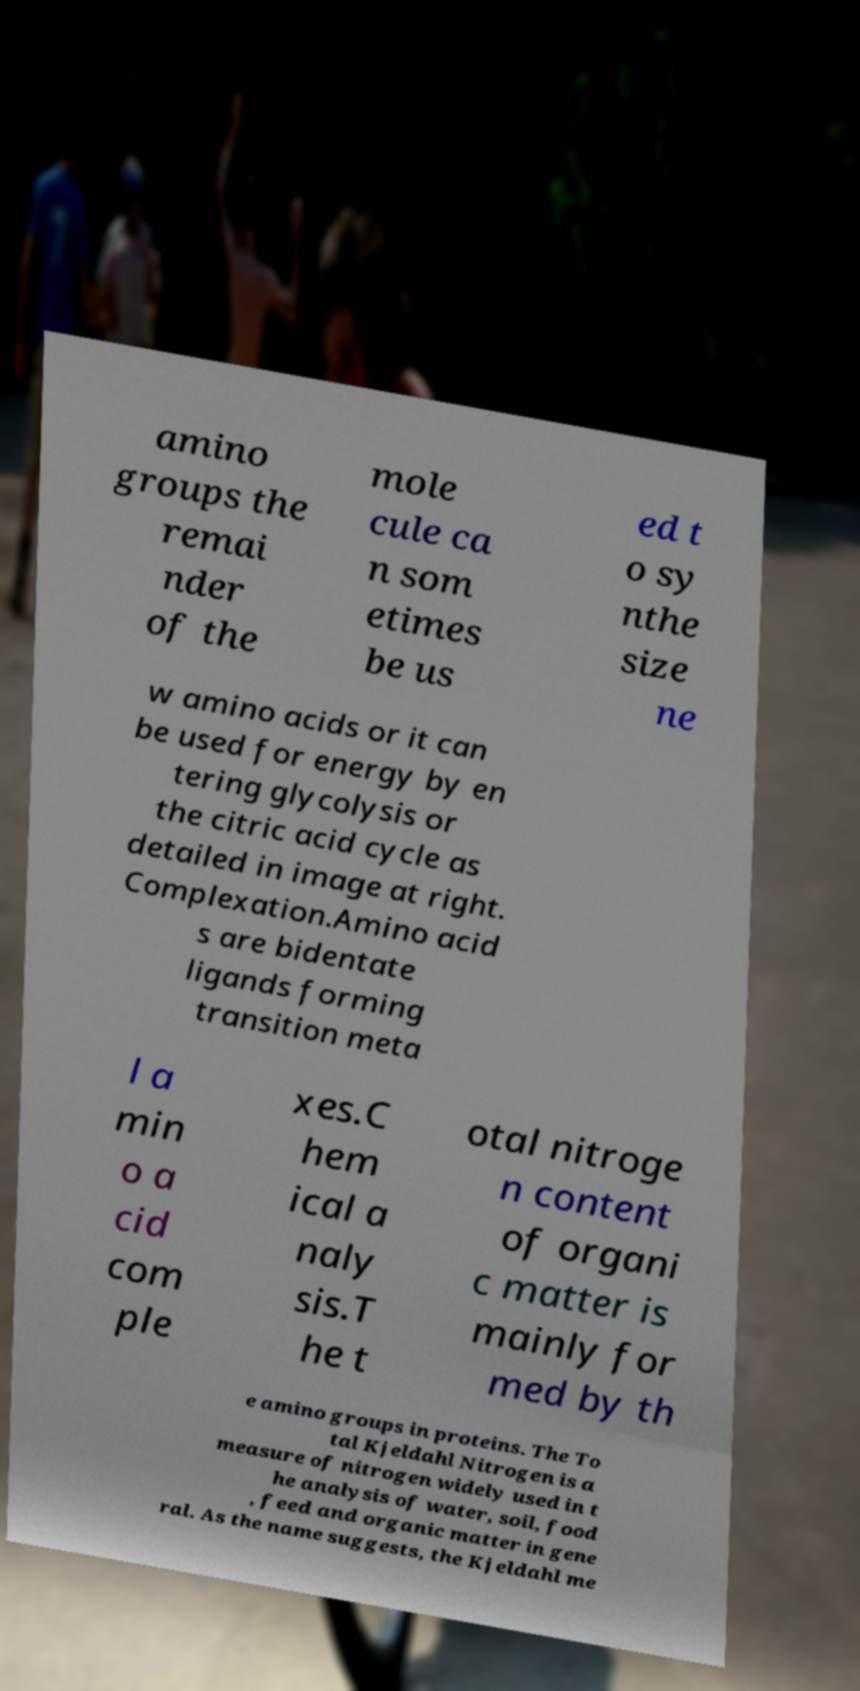What messages or text are displayed in this image? I need them in a readable, typed format. amino groups the remai nder of the mole cule ca n som etimes be us ed t o sy nthe size ne w amino acids or it can be used for energy by en tering glycolysis or the citric acid cycle as detailed in image at right. Complexation.Amino acid s are bidentate ligands forming transition meta l a min o a cid com ple xes.C hem ical a naly sis.T he t otal nitroge n content of organi c matter is mainly for med by th e amino groups in proteins. The To tal Kjeldahl Nitrogen is a measure of nitrogen widely used in t he analysis of water, soil, food , feed and organic matter in gene ral. As the name suggests, the Kjeldahl me 